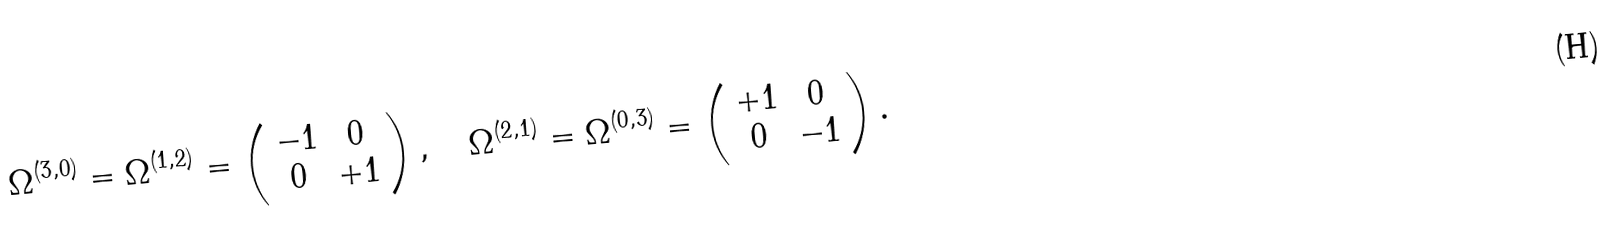<formula> <loc_0><loc_0><loc_500><loc_500>\Omega ^ { ( 3 , 0 ) } = \Omega ^ { ( 1 , 2 ) } = \left ( \begin{array} { c c } - 1 & 0 \\ 0 & + 1 \end{array} \right ) , \quad \Omega ^ { ( 2 , 1 ) } = \Omega ^ { ( 0 , 3 ) } = \left ( \begin{array} { c c } + 1 & 0 \\ 0 & - 1 \end{array} \right ) .</formula> 